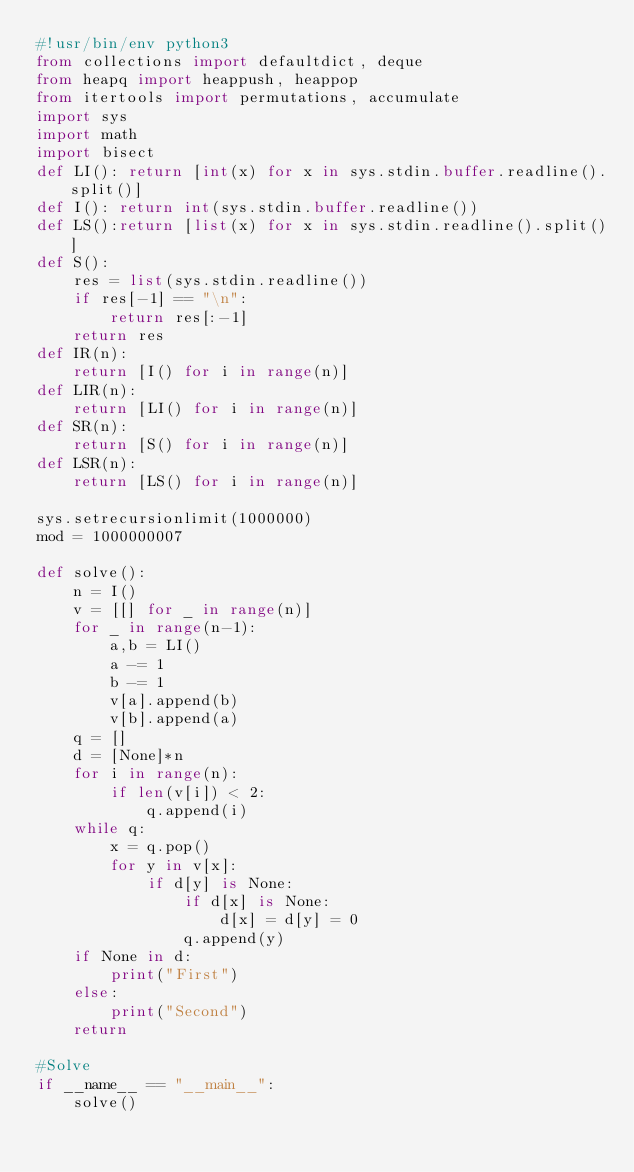Convert code to text. <code><loc_0><loc_0><loc_500><loc_500><_Python_>#!usr/bin/env python3
from collections import defaultdict, deque
from heapq import heappush, heappop
from itertools import permutations, accumulate
import sys
import math
import bisect
def LI(): return [int(x) for x in sys.stdin.buffer.readline().split()]
def I(): return int(sys.stdin.buffer.readline())
def LS():return [list(x) for x in sys.stdin.readline().split()]
def S():
    res = list(sys.stdin.readline())
    if res[-1] == "\n":
        return res[:-1]
    return res
def IR(n):
    return [I() for i in range(n)]
def LIR(n):
    return [LI() for i in range(n)]
def SR(n):
    return [S() for i in range(n)]
def LSR(n):
    return [LS() for i in range(n)]

sys.setrecursionlimit(1000000)
mod = 1000000007

def solve():
    n = I()
    v = [[] for _ in range(n)]
    for _ in range(n-1):
        a,b = LI()
        a -= 1
        b -= 1
        v[a].append(b)
        v[b].append(a)
    q = []
    d = [None]*n
    for i in range(n):
        if len(v[i]) < 2:
            q.append(i)
    while q:
        x = q.pop()
        for y in v[x]:
            if d[y] is None:
                if d[x] is None:
                    d[x] = d[y] = 0
                q.append(y)
    if None in d:
        print("First")
    else:
        print("Second")
    return

#Solve
if __name__ == "__main__":
    solve()
</code> 